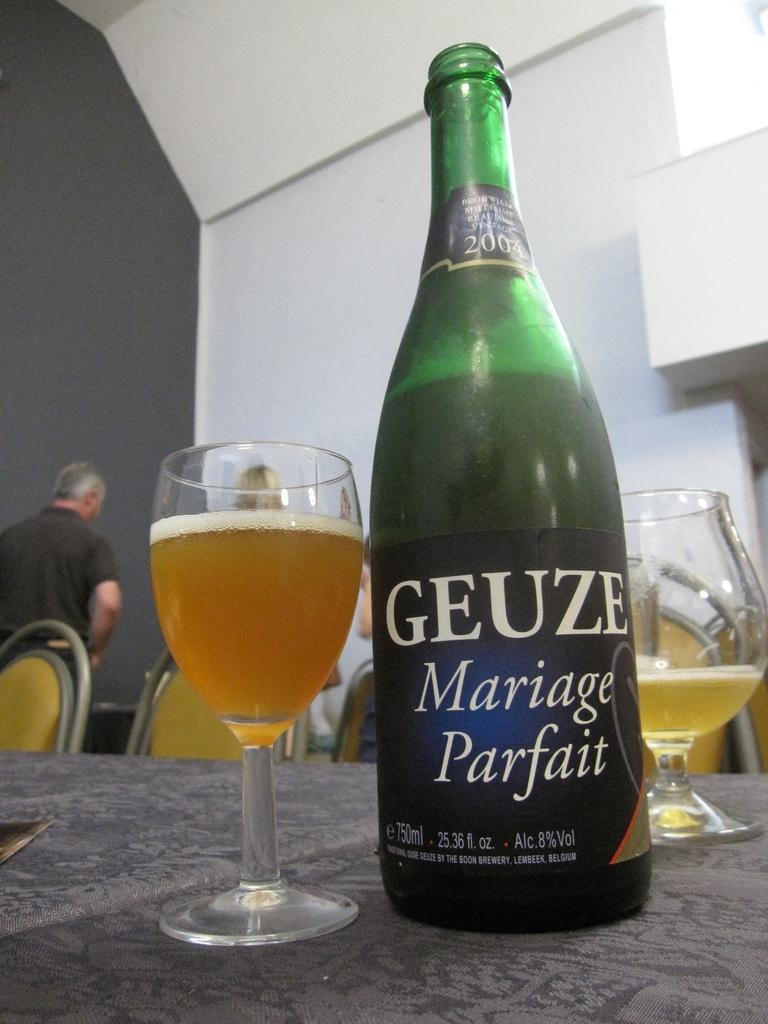Please provide a concise description of this image. Here we can see a bottle of champagne and couple of glasses filled with champagne placed on a table and behind it we can see chairs and a person present 